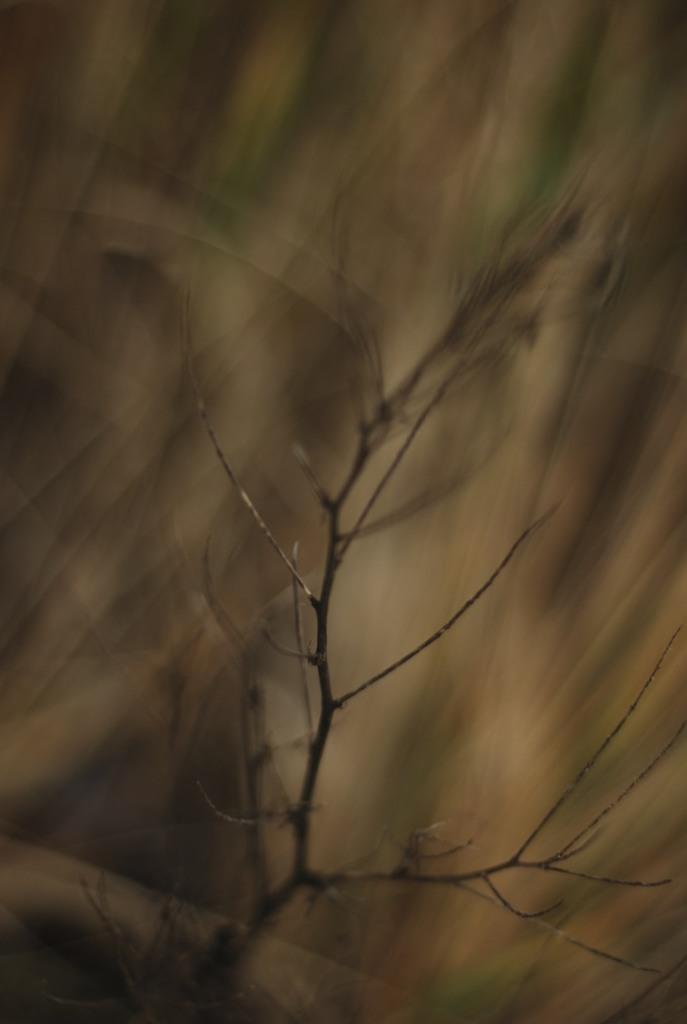Please provide a concise description of this image. In this blurred image there is a dry branch of a tree. 